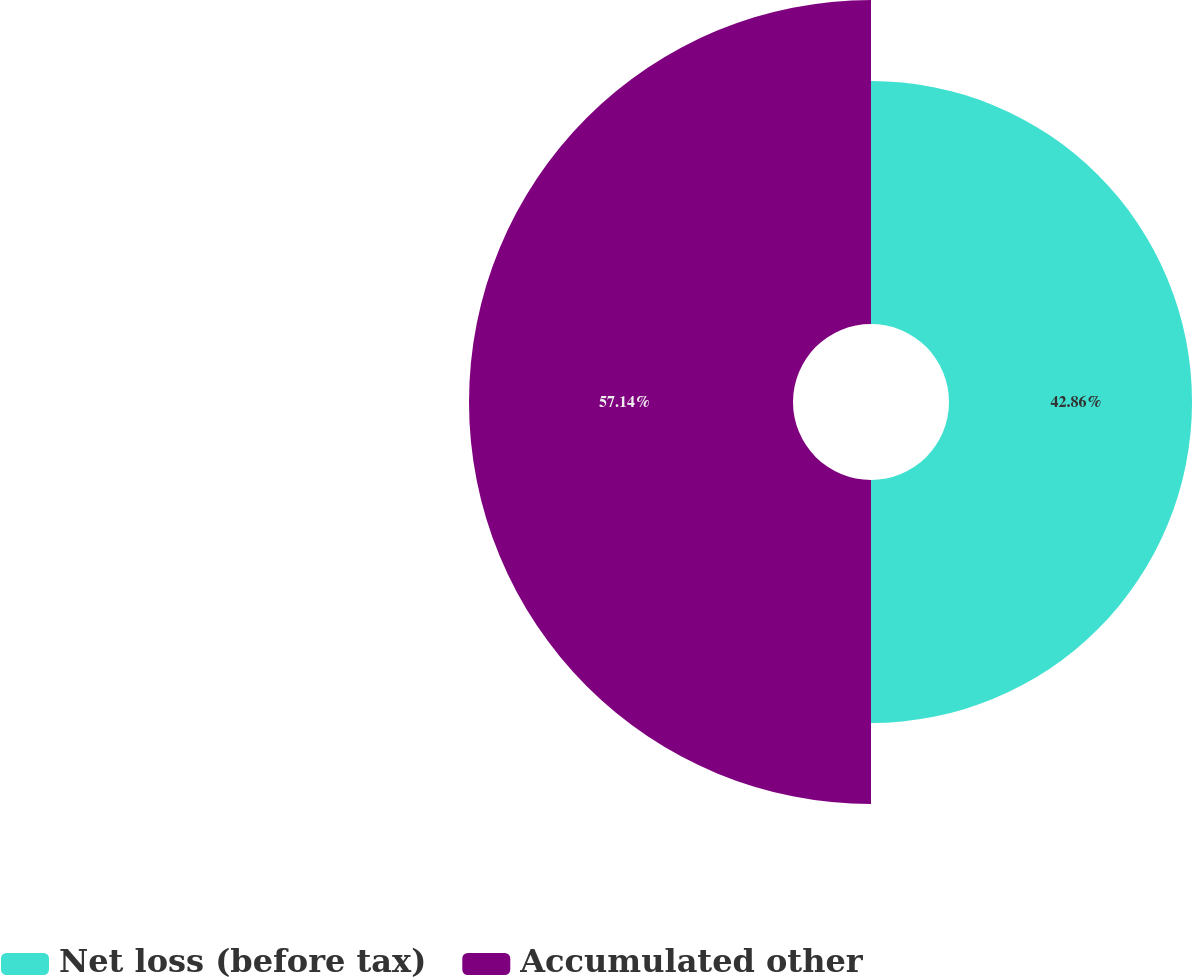<chart> <loc_0><loc_0><loc_500><loc_500><pie_chart><fcel>Net loss (before tax)<fcel>Accumulated other<nl><fcel>42.86%<fcel>57.14%<nl></chart> 